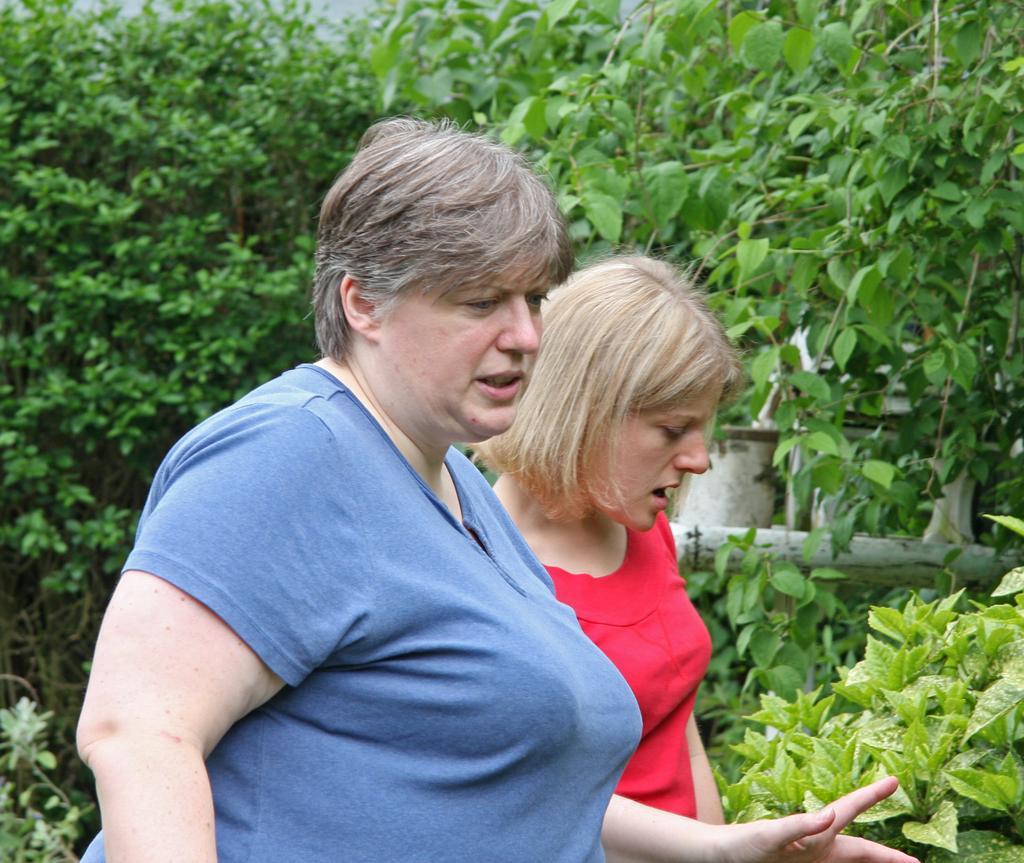Describe this image in one or two sentences. In this picture I can observe two women. There are some plants and trees in the background. One of the women is wearing blue color T shirt and the other is wearing red color T shirt. 